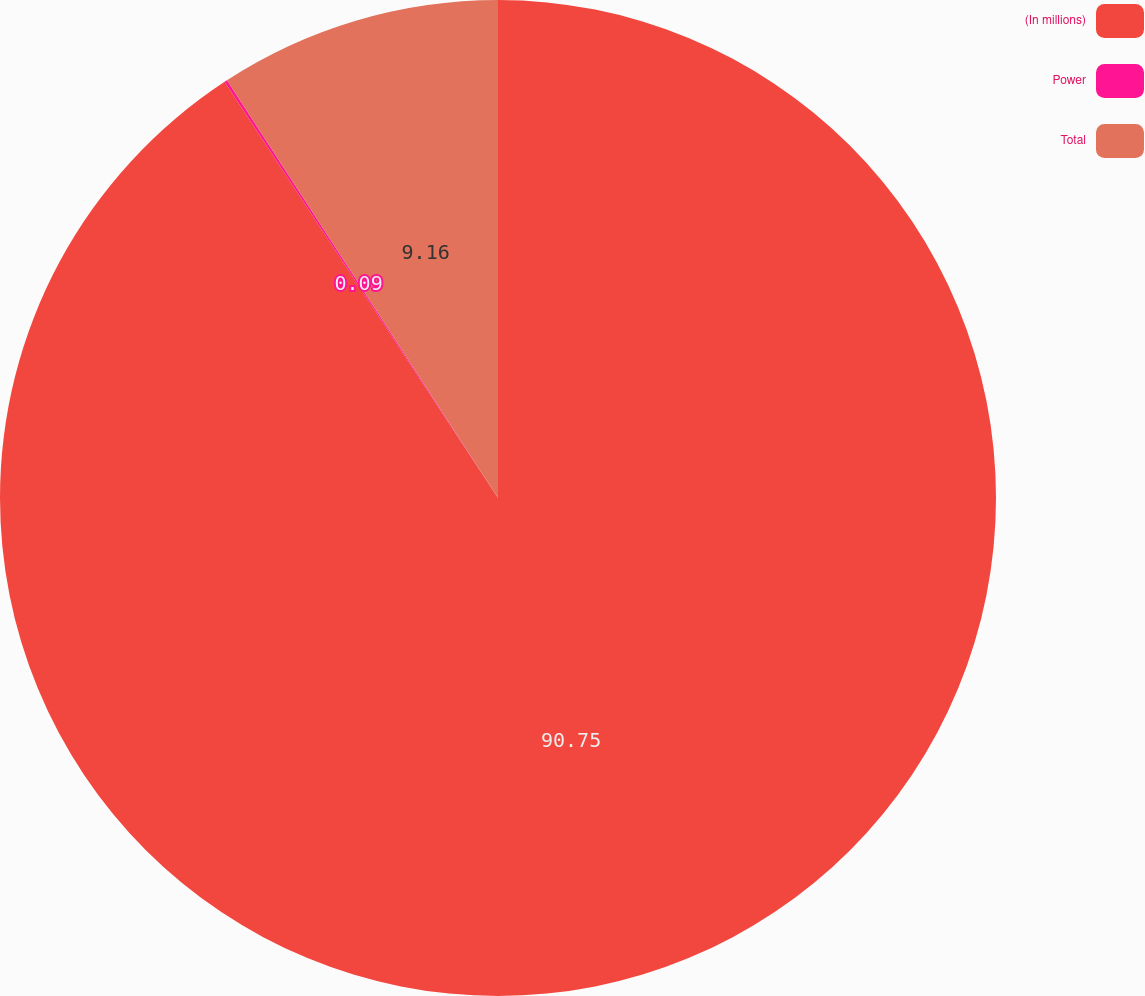<chart> <loc_0><loc_0><loc_500><loc_500><pie_chart><fcel>(In millions)<fcel>Power<fcel>Total<nl><fcel>90.75%<fcel>0.09%<fcel>9.16%<nl></chart> 